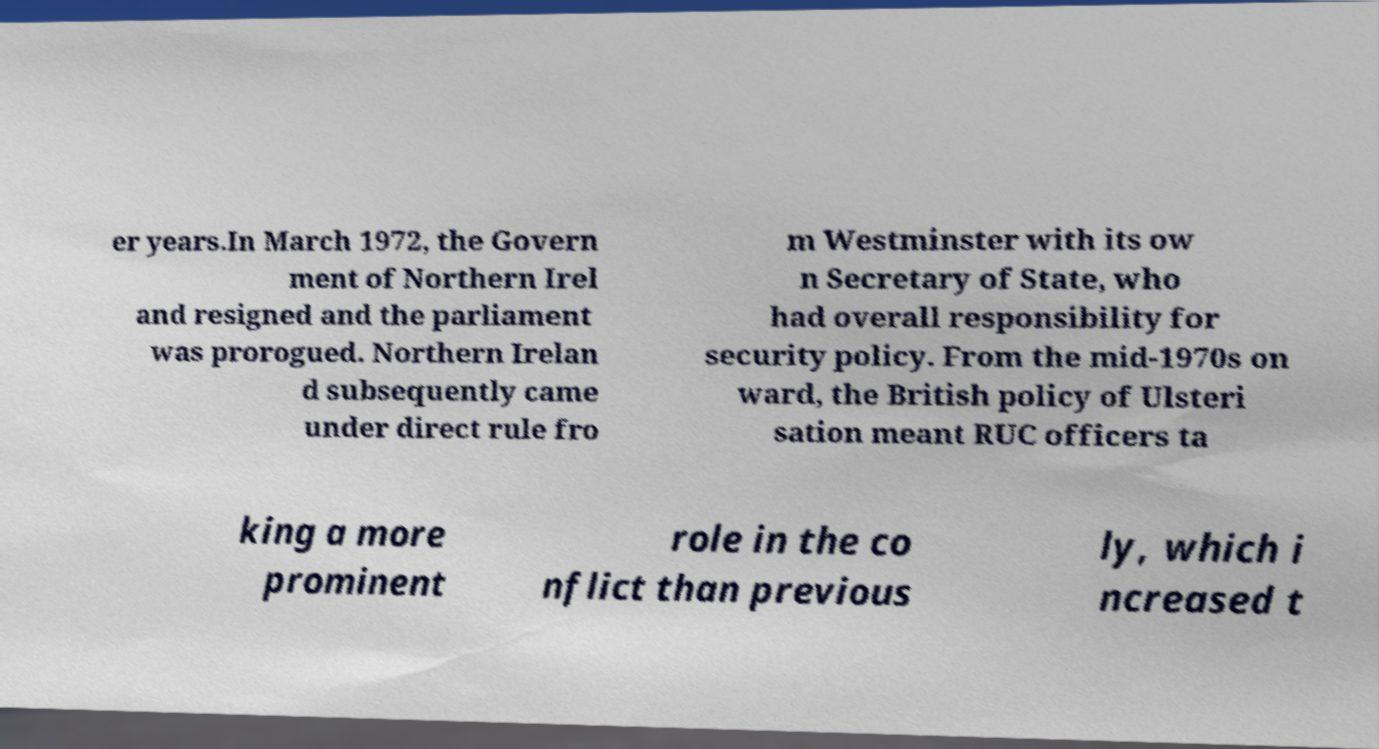For documentation purposes, I need the text within this image transcribed. Could you provide that? er years.In March 1972, the Govern ment of Northern Irel and resigned and the parliament was prorogued. Northern Irelan d subsequently came under direct rule fro m Westminster with its ow n Secretary of State, who had overall responsibility for security policy. From the mid-1970s on ward, the British policy of Ulsteri sation meant RUC officers ta king a more prominent role in the co nflict than previous ly, which i ncreased t 